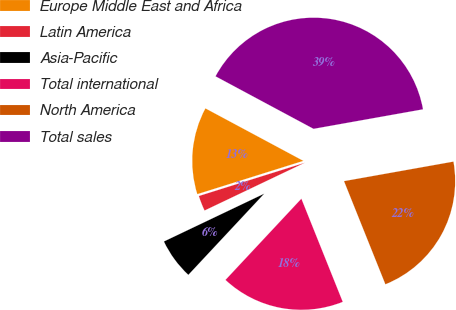Convert chart. <chart><loc_0><loc_0><loc_500><loc_500><pie_chart><fcel>Europe Middle East and Africa<fcel>Latin America<fcel>Asia-Pacific<fcel>Total international<fcel>North America<fcel>Total sales<nl><fcel>12.67%<fcel>2.24%<fcel>5.96%<fcel>18.03%<fcel>21.74%<fcel>39.36%<nl></chart> 